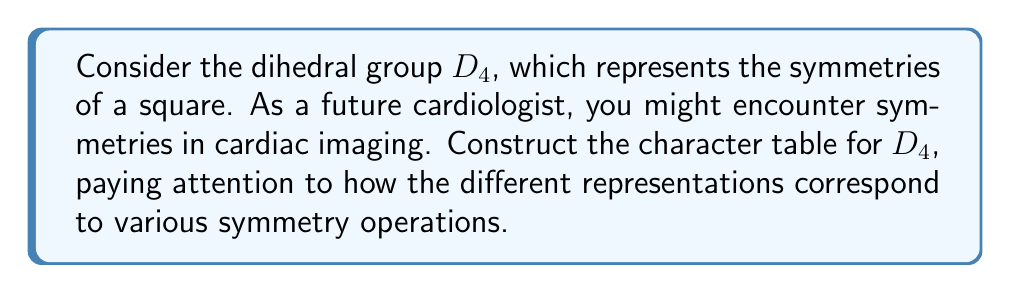Can you answer this question? To construct the character table for $D_4$, we'll follow these steps:

1) First, identify the elements of $D_4$:
   $e$ (identity), $r$ (90° rotation), $r^2$ (180° rotation), $r^3$ (270° rotation),
   $s$ (reflection about vertical axis), $sr$ (reflection about diagonal),
   $sr^2$ (reflection about horizontal axis), $sr^3$ (reflection about other diagonal)

2) Determine the conjugacy classes:
   $\{e\}$, $\{r, r^3\}$, $\{r^2\}$, $\{s, sr^2\}$, $\{sr, sr^3\}$

3) The number of irreducible representations equals the number of conjugacy classes, so we have 5 irreducible representations.

4) We know that $D_4$ has order 8, so the sum of squares of dimensions of irreducible representations must equal 8.

5) There are always two 1-dimensional representations: the trivial representation and the sign representation. Let's call the others $\chi_2$, $\chi_3$, and $\chi_4$.

6) The remaining representation must be 2-dimensional to satisfy $1^2 + 1^2 + 1^2 + 1^2 + 2^2 = 8$.

7) For the trivial representation, all characters are 1.

8) For the sign representation, rotations have character 1, and reflections have character -1.

9) For $\chi_2$, we can assign 1 to $e$ and $r^2$, and -1 to the rest.

10) For $\chi_3$, we can assign 1 to $e$, $s$, and $sr^2$, and -1 to the rest.

11) For the 2-dimensional representation $\chi_4$, we can use the trace of the corresponding matrices:
    $\chi_4(e) = 2$, $\chi_4(r) = \chi_4(r^3) = 0$, $\chi_4(r^2) = -2$, 
    $\chi_4(s) = \chi_4(sr^2) = 0$, $\chi_4(sr) = \chi_4(sr^3) = 0$

The resulting character table is:

$$
\begin{array}{c|ccccc}
D_4 & \{e\} & \{r, r^3\} & \{r^2\} & \{s, sr^2\} & \{sr, sr^3\} \\
\hline
\chi_1 & 1 & 1 & 1 & 1 & 1 \\
\chi_2 & 1 & -1 & 1 & 1 & -1 \\
\chi_3 & 1 & -1 & 1 & -1 & 1 \\
\chi_4 & 1 & 1 & 1 & -1 & -1 \\
\chi_5 & 2 & 0 & -2 & 0 & 0
\end{array}
$$
Answer: $$
\begin{array}{c|ccccc}
D_4 & \{e\} & \{r, r^3\} & \{r^2\} & \{s, sr^2\} & \{sr, sr^3\} \\
\hline
\chi_1 & 1 & 1 & 1 & 1 & 1 \\
\chi_2 & 1 & -1 & 1 & 1 & -1 \\
\chi_3 & 1 & -1 & 1 & -1 & 1 \\
\chi_4 & 1 & 1 & 1 & -1 & -1 \\
\chi_5 & 2 & 0 & -2 & 0 & 0
\end{array}
$$ 